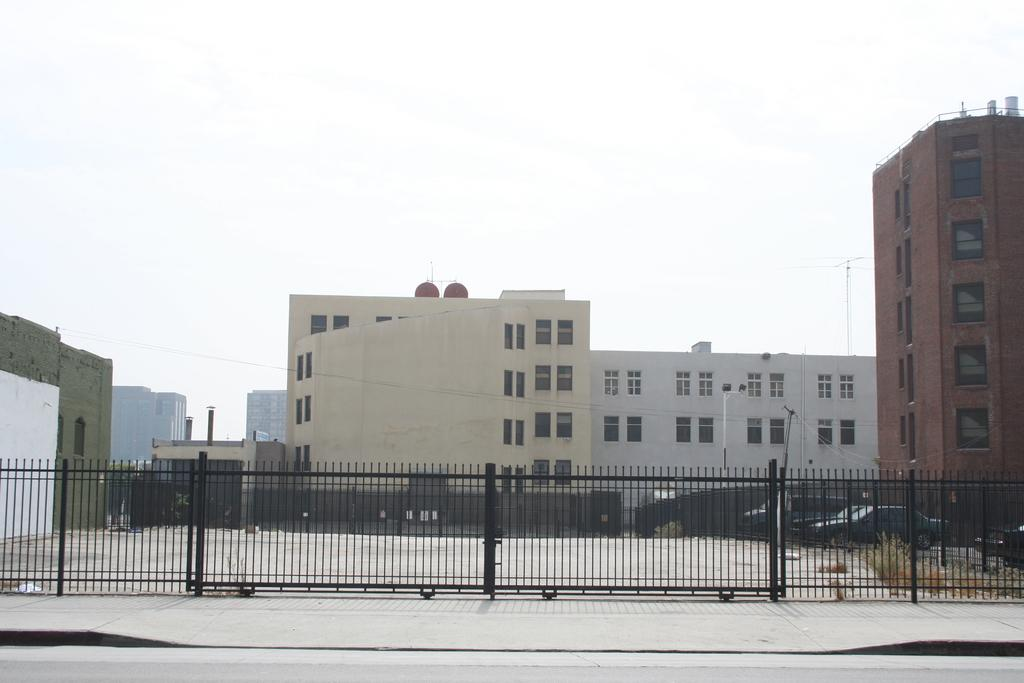What types of objects can be seen in the image? There are vehicles, iron grilles, and buildings in the image. Can you describe the surroundings in the image? The sky is visible in the background of the image. What might be the purpose of the iron grilles in the image? The iron grilles could be for security or decoration. What type of power source is visible in the image? There is no power source visible in the image. How many bridges can be seen in the image? There are no bridges present in the image. 